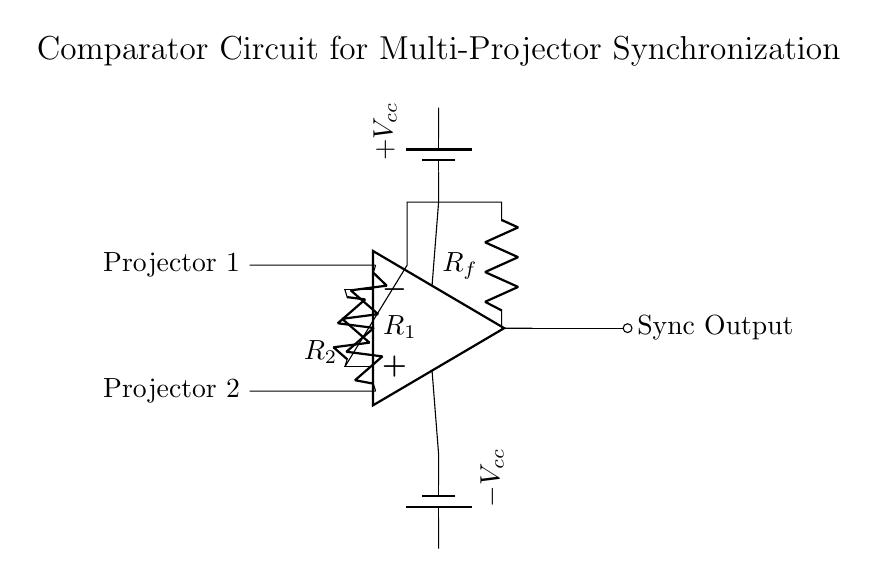What is the type of operational amplifier used? The circuit diagram depicts a standard op-amp symbol, which is a generic representation of operational amplifiers. It is not specific to a particular type, but it indicates that an op-amp is being used for comparison.
Answer: op-amp How many input resistors are there? The diagram shows two resistors labeled R1 and R2 connected to the non-inverting and inverting terminals of the op-amp, respectively. Therefore, there are two input resistors.
Answer: 2 What does the sync output signify? The sync output serves as a signal that indicates when the outputs of the two projectors are synchronized based on the comparison performed by the op-amp circuit. This output helps to ensure that both projectors display images in harmony.
Answer: Sync Output What is the purpose of Rf? Rf, labeled as a feedback resistor, helps to determine the gain of the op-amp circuit, allowing for stability and control over the output signal based on the difference between the two input signals.
Answer: Feedback resistor What are the voltage supply levels labeled as? The voltage supplies are labeled as Vcc and minus Vcc, which indicate the positive and negative power supply levels required for the operation of the op-amp. These supplies are essential for proper functioning.
Answer: Plus Vcc and minus Vcc How is the feedback connected in the circuit? The feedback is connected from the output of the op-amp through the feedback resistor Rf back to the non-inverting terminal of the op-amp. This feedback loop is critical for stabilizing the output and ensuring the desired operation of the comparator.
Answer: Feedback to non-inverting terminal 